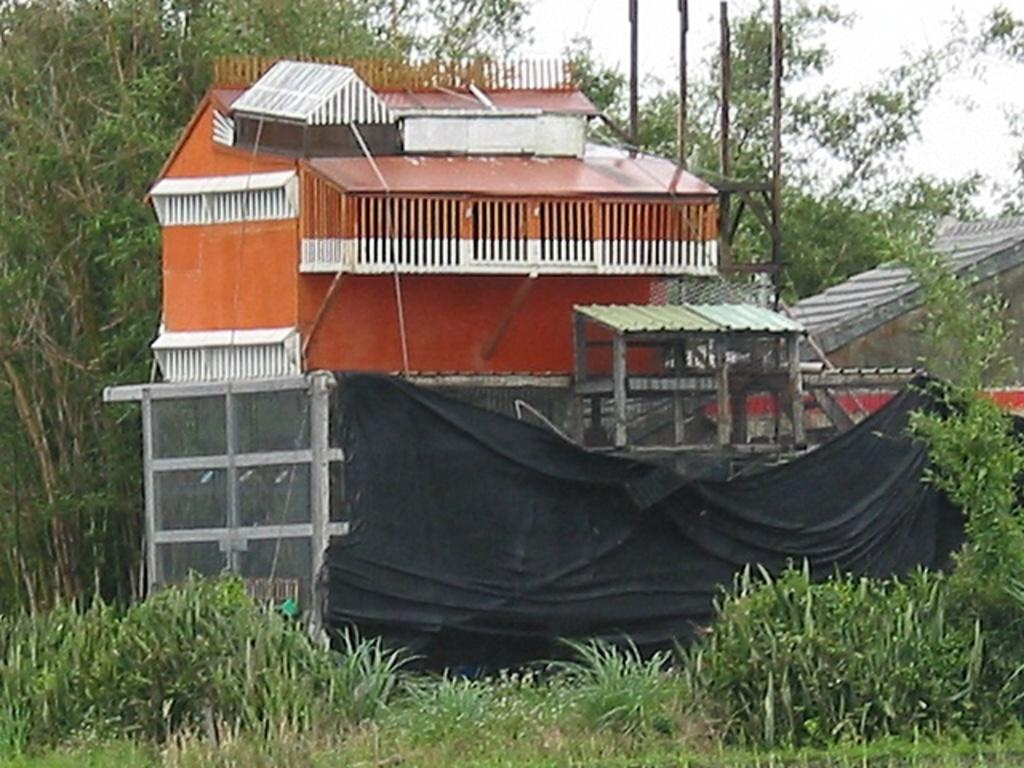What type of vegetation is at the bottom of the image? There is grass at the bottom of the image. What can be seen in the background of the image? There are groups of trees in the background of the image. What structure is located in the middle of the image? There is a house in the middle of the image. What type of government is depicted in the image? There is no depiction of a government in the image; it features grass, trees, and a house. What mode of transport can be seen in the image? There is no mode of transport present in the image. 